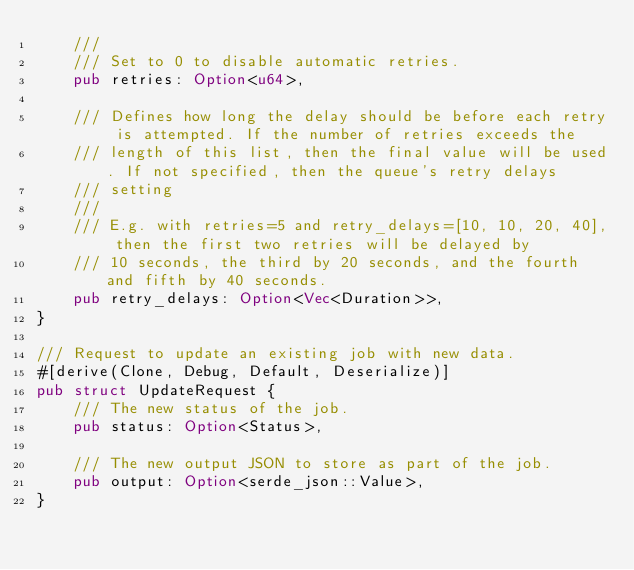<code> <loc_0><loc_0><loc_500><loc_500><_Rust_>    ///
    /// Set to 0 to disable automatic retries.
    pub retries: Option<u64>,

    /// Defines how long the delay should be before each retry is attempted. If the number of retries exceeds the
    /// length of this list, then the final value will be used. If not specified, then the queue's retry delays
    /// setting
    ///
    /// E.g. with retries=5 and retry_delays=[10, 10, 20, 40], then the first two retries will be delayed by
    /// 10 seconds, the third by 20 seconds, and the fourth and fifth by 40 seconds.
    pub retry_delays: Option<Vec<Duration>>,
}

/// Request to update an existing job with new data.
#[derive(Clone, Debug, Default, Deserialize)]
pub struct UpdateRequest {
    /// The new status of the job.
    pub status: Option<Status>,

    /// The new output JSON to store as part of the job.
    pub output: Option<serde_json::Value>,
}
</code> 